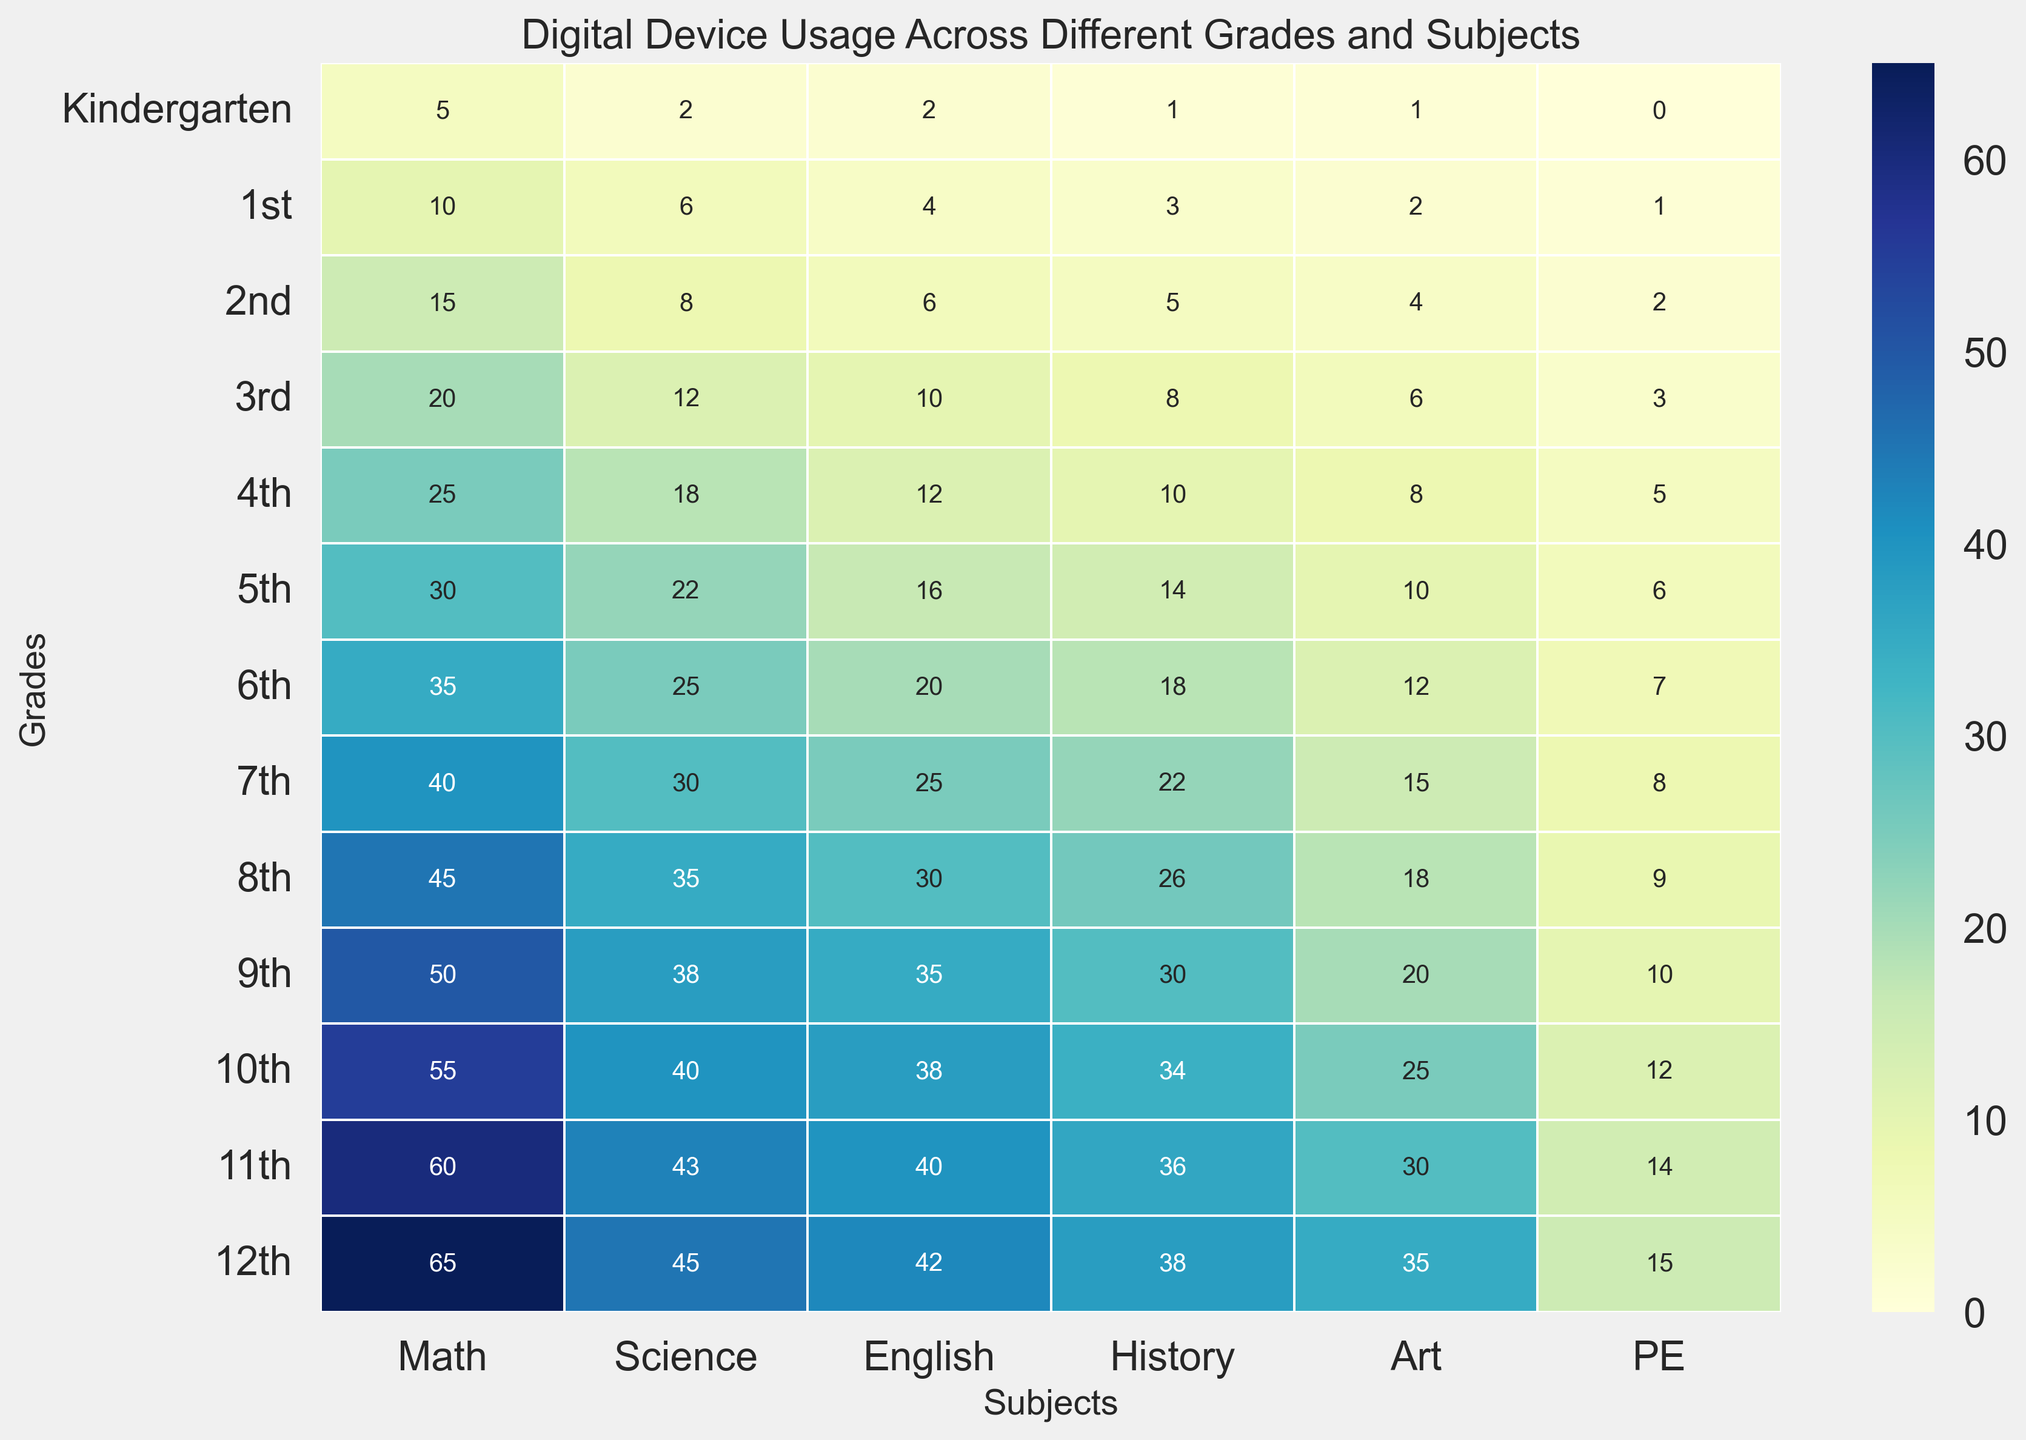what grade shows the highest digital device usage in Science? To determine which grade has the highest usage in Science, look at the Science column for each grade and find the maximum value. The 12th grade has the highest number, which is 45.
Answer: 12th grade which subject has the least digital device usage in 9th grade? Examine the row for 9th grade and identify the smallest value among the subjects. The smallest value here is 10, found in PE.
Answer: PE how does digital device usage in Math for 1st grade compare to 3rd grade? Check the values in the Math column for both 1st and 3rd grades. The usage for 1st grade is 10, and for 3rd grade, it is 20. Since 20 is greater than 10, 3rd grade has higher usage.
Answer: 3rd grade has higher usage what is the difference in digital device usage between Art and PE in 7th grade? For 7th grade, find the values for Art and PE. Art has 15, and PE has 8. The difference is 15 - 8, which equals 7.
Answer: 7 how many times more are digital devices used in 12th grade Math compared to Kindergarten Math? Look at the Math usage in 12th grade and Kindergarten. The values are 65 for 12th grade and 5 for Kindergarten. Divide 65 by 5 to get how many times more: 65 / 5 = 13.
Answer: 13 times 